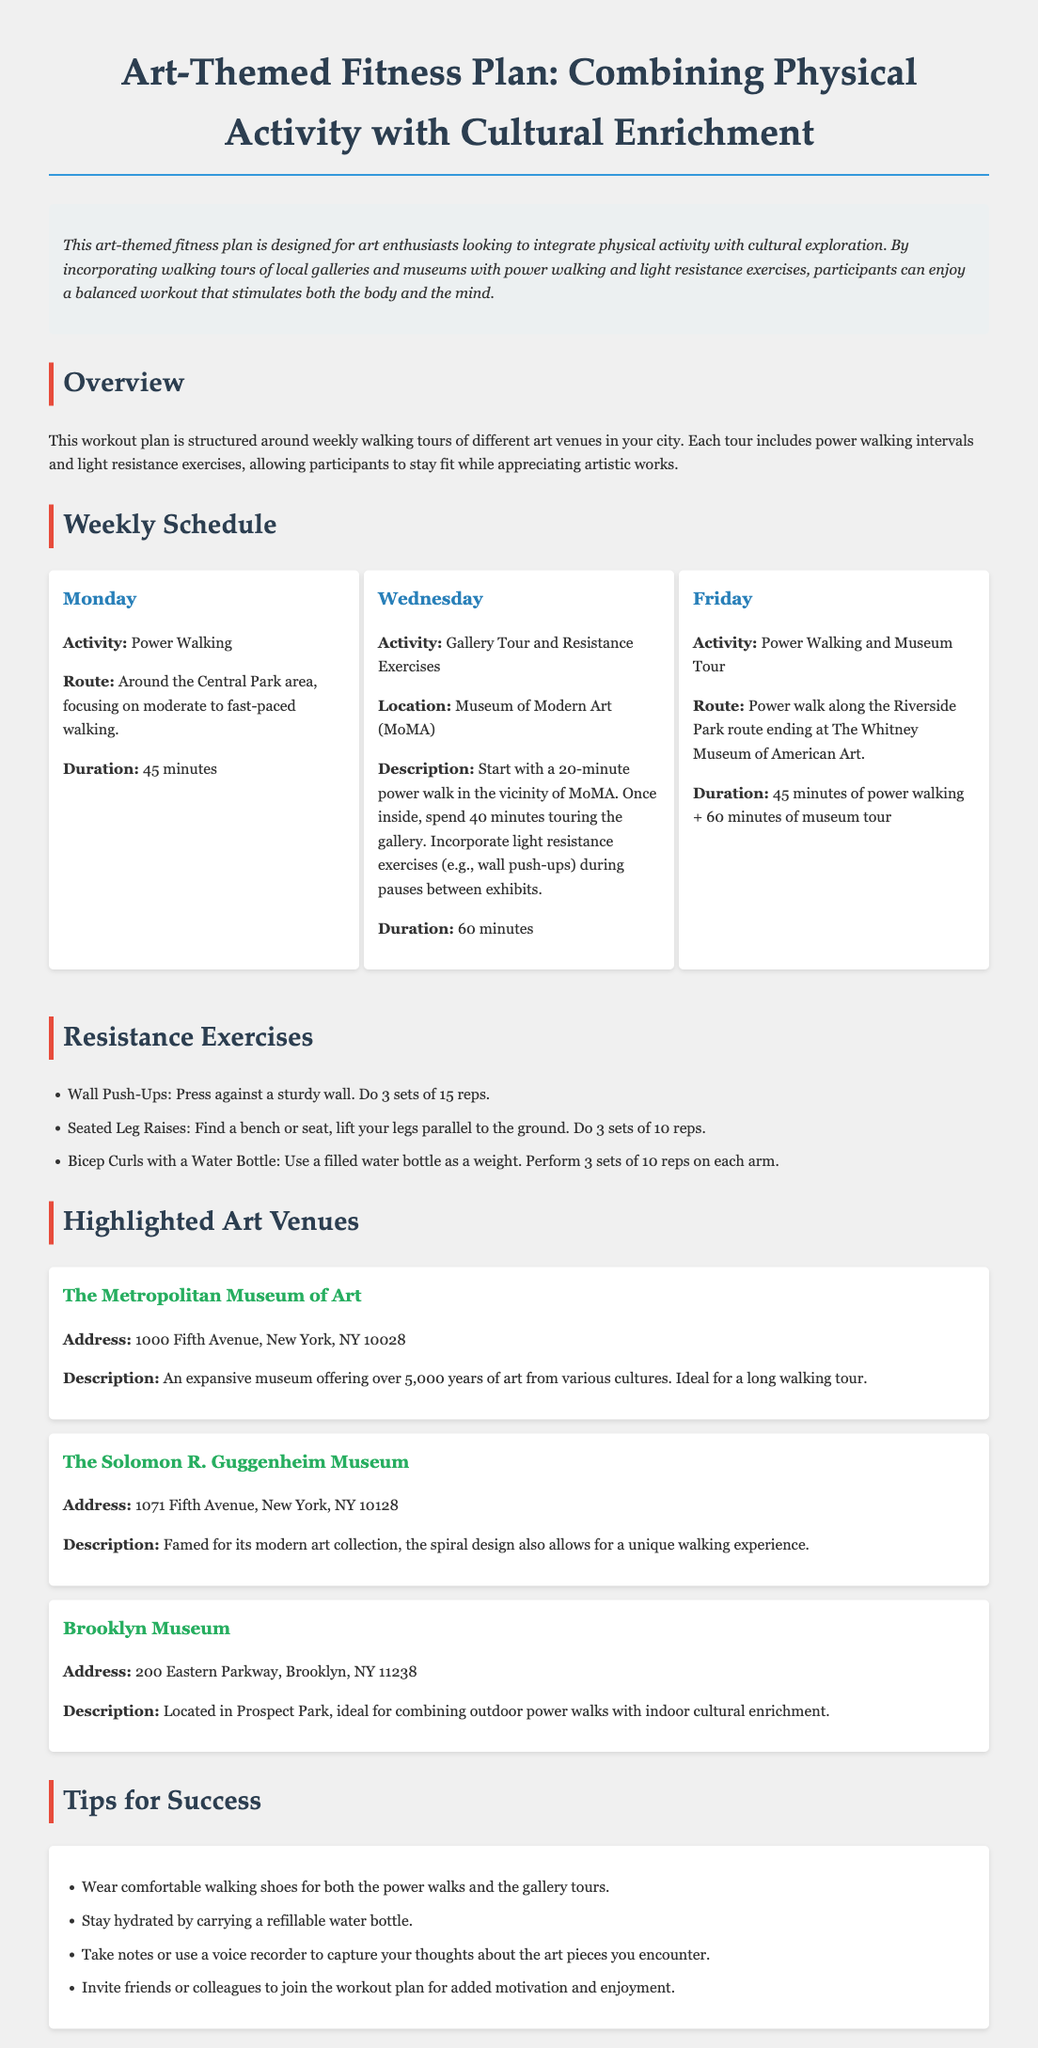what is the title of the workout plan? The title of the workout plan is stated at the beginning of the document.
Answer: Art-Themed Fitness Plan: Combining Physical Activity with Cultural Enrichment what day includes a tour of the Museum of Modern Art? The schedule specifies a gallery tour on Wednesday at the Museum of Modern Art.
Answer: Wednesday how long is the power walking activity on Friday? The document specifies the duration of the power walking activity on Friday.
Answer: 45 minutes what resistance exercise involves using a water bottle? The document lists this resistance exercise among others in the exercise section.
Answer: Bicep Curls with a Water Bottle name one highlighted art venue mentioned in the document. The document contains a section that lists several art venues in detail.
Answer: The Metropolitan Museum of Art what should participants wear for the workouts? The tips section advises on proper attire for art-themed fitness activities.
Answer: Comfortable walking shoes how long is the gallery tour on Wednesday? The document specifies the duration of the gallery tour within the Wednesday schedule.
Answer: 40 minutes what is recommended for staying hydrated? The tips section suggests a method for ensuring hydration during the activities.
Answer: Carrying a refillable water bottle how many reps are suggested for wall push-ups? The resistance exercises section outlines the number of reps for this exercise.
Answer: 15 reps 